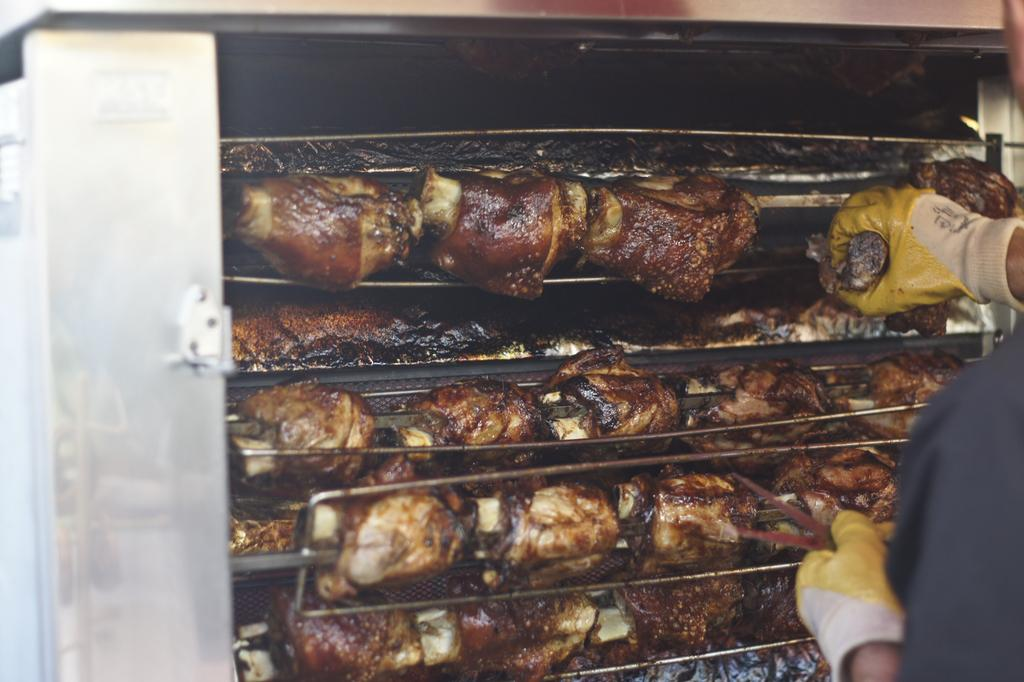What is inside the oven in the image? There is meat in the oven in the image. What is the man holding in his hand? The man is holding meat in his hand. What is the man wearing on his hands? The man is wearing gloves on his hands. What type of apple is being distributed by the man in the image? There is no apple present in the image; the man is holding meat and wearing gloves. What kind of toy can be seen in the man's hand in the image? There is no toy present in the image; the man is holding meat and wearing gloves. 